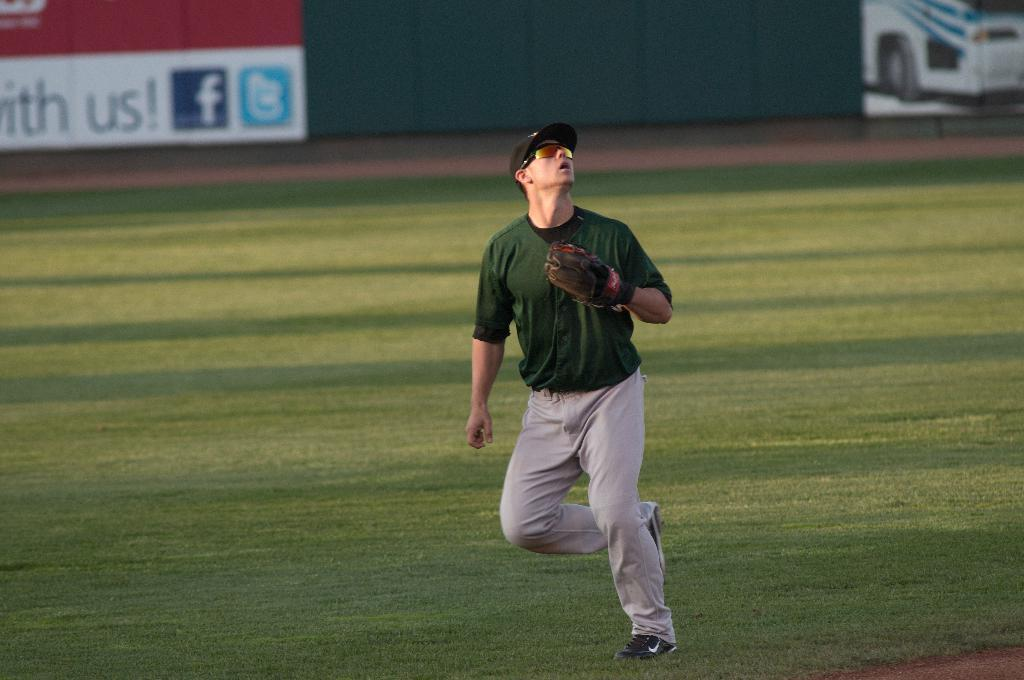Provide a one-sentence caption for the provided image. A facebook logo can be seen next to the word us on a sign in a baseball diamond. 